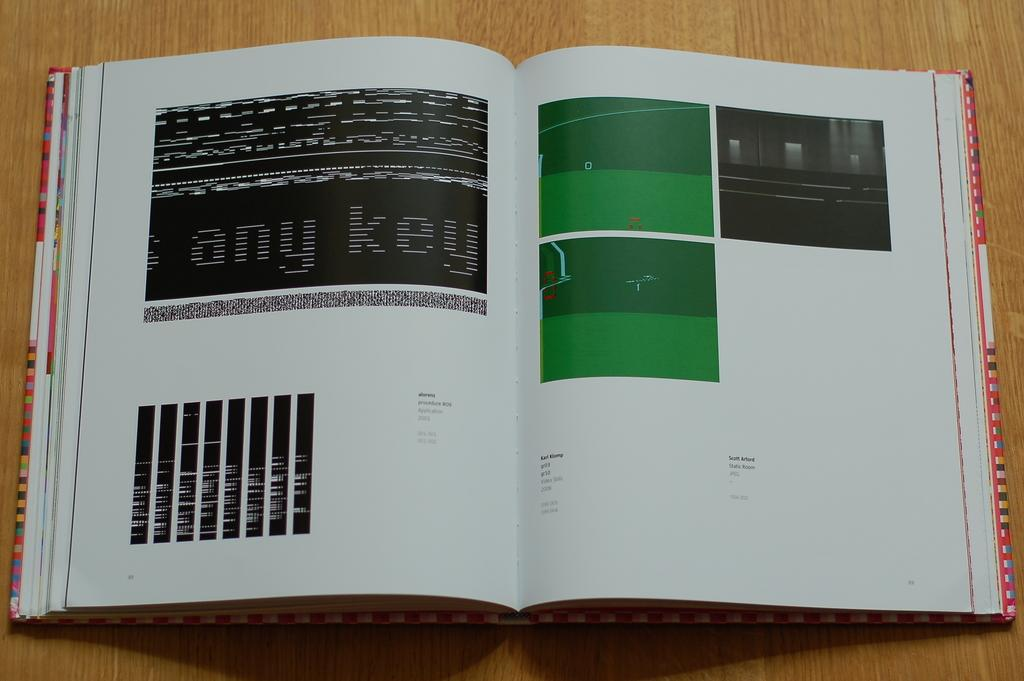<image>
Write a terse but informative summary of the picture. a book open to a page with any key as text 